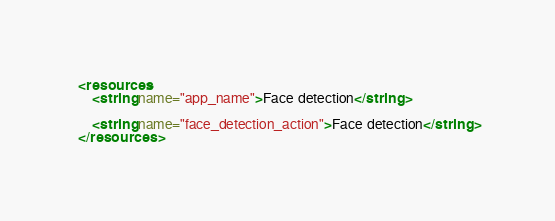Convert code to text. <code><loc_0><loc_0><loc_500><loc_500><_XML_><resources>
	<string name="app_name">Face detection</string>

	<string name="face_detection_action">Face detection</string>
</resources>
</code> 